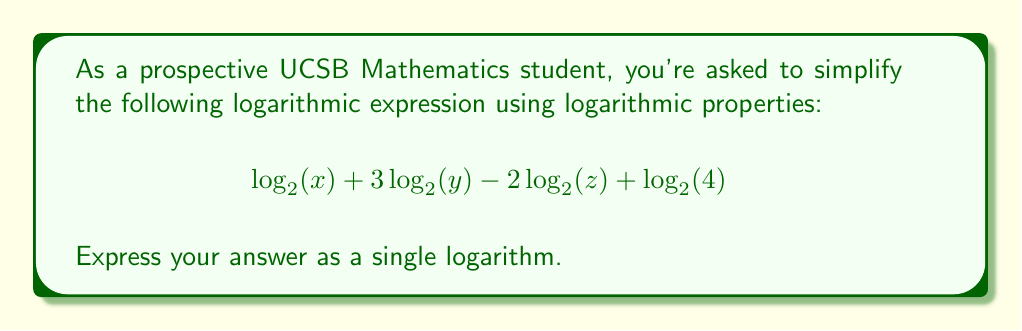Show me your answer to this math problem. Let's approach this step-by-step using logarithmic properties:

1) First, recall the following logarithmic properties:
   - Product rule: $\log_a(M) + \log_a(N) = \log_a(MN)$
   - Quotient rule: $\log_a(M) - \log_a(N) = \log_a(\frac{M}{N})$
   - Power rule: $n\log_a(M) = \log_a(M^n)$

2) We can apply the power rule to $3\log_2(y)$ and $-2\log_2(z)$:
   $$\log_2(x) + \log_2(y^3) - \log_2(z^2) + \log_2(4)$$

3) Now we can use the product rule to combine all positive terms:
   $$\log_2(xy^3 \cdot 4) - \log_2(z^2)$$

4) Simplify inside the first logarithm:
   $$\log_2(4xy^3) - \log_2(z^2)$$

5) Finally, we can use the quotient rule to combine these into a single logarithm:
   $$\log_2(\frac{4xy^3}{z^2})$$

This is our final, simplified expression.
Answer: $$\log_2(\frac{4xy^3}{z^2})$$ 